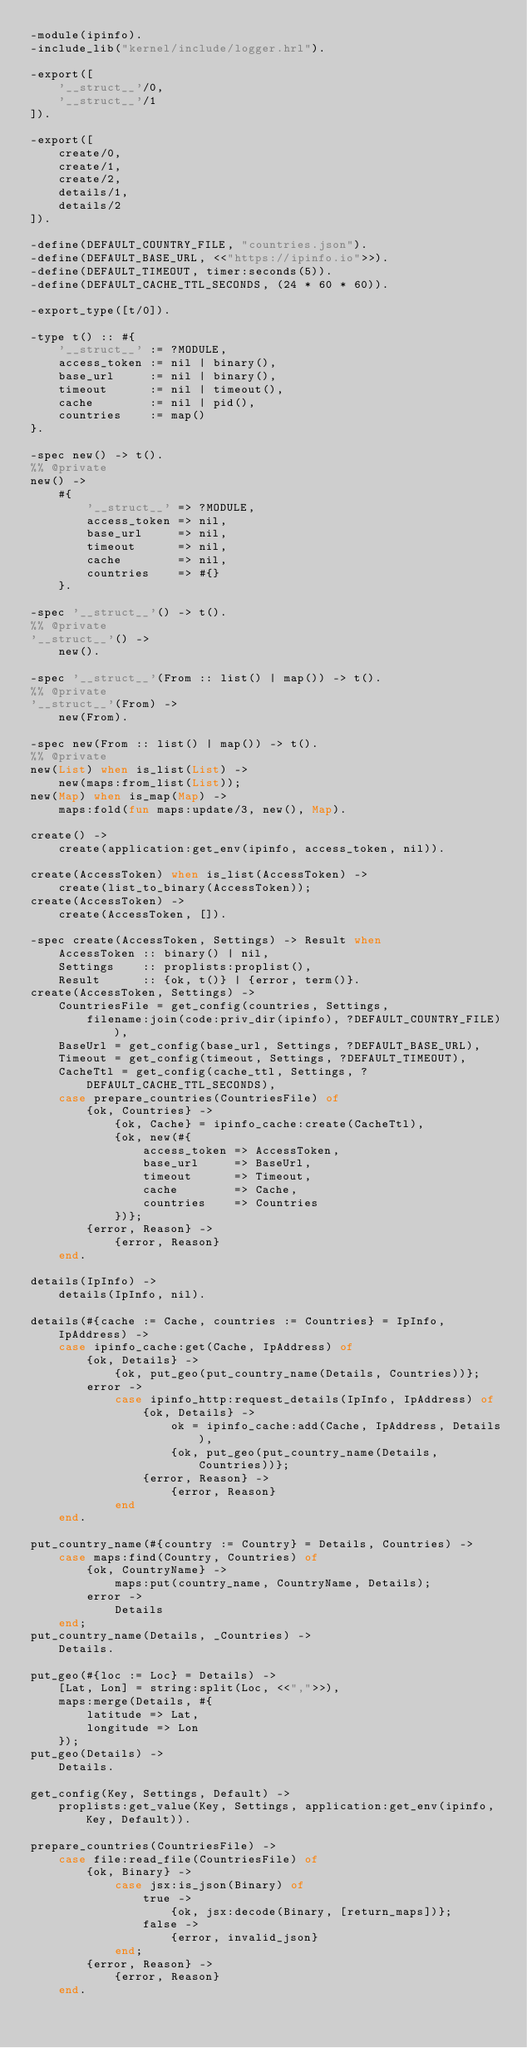<code> <loc_0><loc_0><loc_500><loc_500><_Erlang_>-module(ipinfo).
-include_lib("kernel/include/logger.hrl").

-export([
    '__struct__'/0,
    '__struct__'/1
]).

-export([
    create/0,
    create/1,
    create/2,
    details/1,
    details/2
]).

-define(DEFAULT_COUNTRY_FILE, "countries.json").
-define(DEFAULT_BASE_URL, <<"https://ipinfo.io">>).
-define(DEFAULT_TIMEOUT, timer:seconds(5)).
-define(DEFAULT_CACHE_TTL_SECONDS, (24 * 60 * 60)).

-export_type([t/0]).

-type t() :: #{
    '__struct__' := ?MODULE,
    access_token := nil | binary(),
    base_url     := nil | binary(),
    timeout      := nil | timeout(),
    cache        := nil | pid(),
    countries    := map()
}.

-spec new() -> t().
%% @private
new() ->
    #{
        '__struct__' => ?MODULE,
        access_token => nil,
        base_url     => nil,
        timeout      => nil,
        cache        => nil,
        countries    => #{}
    }.

-spec '__struct__'() -> t().
%% @private
'__struct__'() ->
    new().

-spec '__struct__'(From :: list() | map()) -> t().
%% @private
'__struct__'(From) ->
    new(From).

-spec new(From :: list() | map()) -> t().
%% @private
new(List) when is_list(List) ->
    new(maps:from_list(List));
new(Map) when is_map(Map) ->
    maps:fold(fun maps:update/3, new(), Map).

create() ->
    create(application:get_env(ipinfo, access_token, nil)).

create(AccessToken) when is_list(AccessToken) ->
    create(list_to_binary(AccessToken));
create(AccessToken) ->
    create(AccessToken, []).

-spec create(AccessToken, Settings) -> Result when
    AccessToken :: binary() | nil,
    Settings    :: proplists:proplist(),
    Result      :: {ok, t()} | {error, term()}.
create(AccessToken, Settings) ->
    CountriesFile = get_config(countries, Settings,
        filename:join(code:priv_dir(ipinfo), ?DEFAULT_COUNTRY_FILE)),
    BaseUrl = get_config(base_url, Settings, ?DEFAULT_BASE_URL),
    Timeout = get_config(timeout, Settings, ?DEFAULT_TIMEOUT),
    CacheTtl = get_config(cache_ttl, Settings, ?DEFAULT_CACHE_TTL_SECONDS),
    case prepare_countries(CountriesFile) of
        {ok, Countries} ->
            {ok, Cache} = ipinfo_cache:create(CacheTtl),
            {ok, new(#{
                access_token => AccessToken,
                base_url     => BaseUrl,
                timeout      => Timeout,
                cache        => Cache,
                countries    => Countries
            })};
        {error, Reason} ->
            {error, Reason}
    end.

details(IpInfo) ->
    details(IpInfo, nil).

details(#{cache := Cache, countries := Countries} = IpInfo, IpAddress) ->
    case ipinfo_cache:get(Cache, IpAddress) of
        {ok, Details} ->
            {ok, put_geo(put_country_name(Details, Countries))};
        error ->
            case ipinfo_http:request_details(IpInfo, IpAddress) of
                {ok, Details} ->
                    ok = ipinfo_cache:add(Cache, IpAddress, Details),
                    {ok, put_geo(put_country_name(Details, Countries))};
                {error, Reason} ->
                    {error, Reason}
            end
    end.

put_country_name(#{country := Country} = Details, Countries) ->
    case maps:find(Country, Countries) of
        {ok, CountryName} ->
            maps:put(country_name, CountryName, Details);
        error ->
            Details
    end;
put_country_name(Details, _Countries) ->
    Details.

put_geo(#{loc := Loc} = Details) ->
    [Lat, Lon] = string:split(Loc, <<",">>),
    maps:merge(Details, #{
        latitude => Lat,
        longitude => Lon
    });
put_geo(Details) ->
    Details.

get_config(Key, Settings, Default) ->
    proplists:get_value(Key, Settings, application:get_env(ipinfo, Key, Default)).

prepare_countries(CountriesFile) ->
    case file:read_file(CountriesFile) of
        {ok, Binary} ->
            case jsx:is_json(Binary) of
                true ->
                    {ok, jsx:decode(Binary, [return_maps])};
                false ->
                    {error, invalid_json}
            end;
        {error, Reason} ->
            {error, Reason}
    end.
</code> 